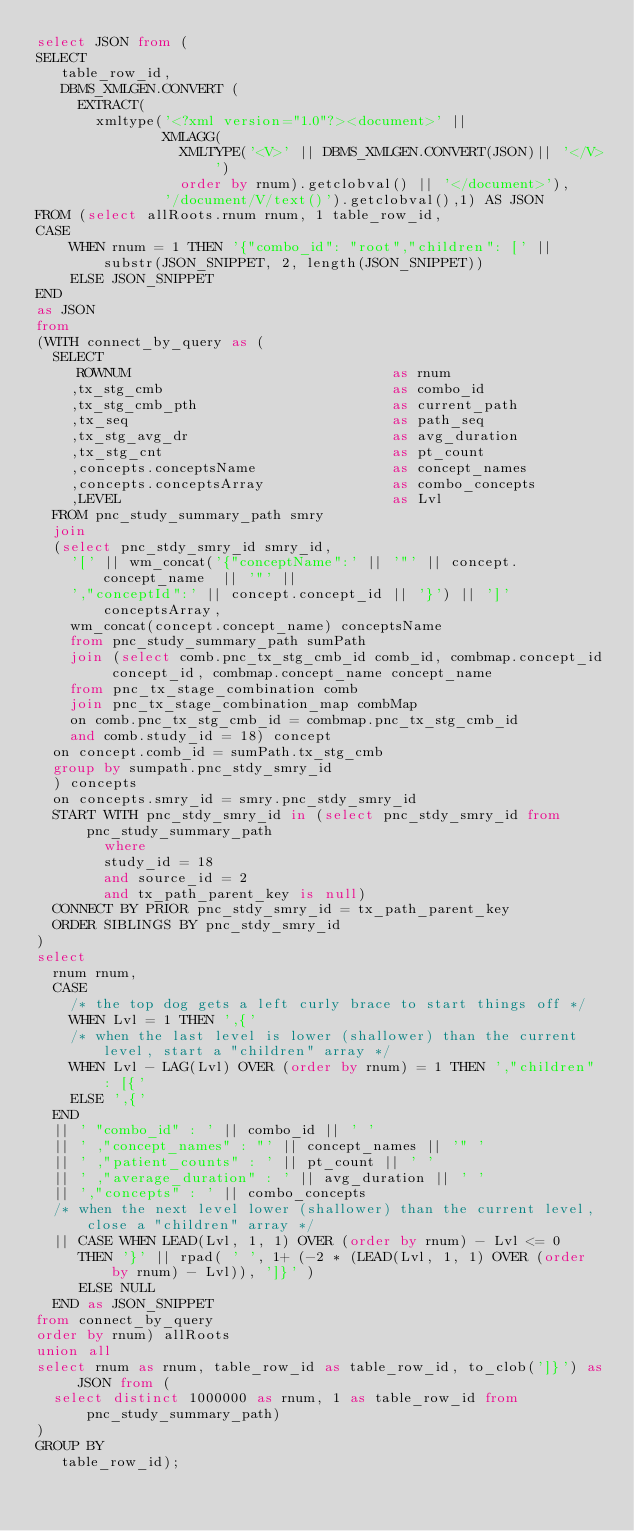Convert code to text. <code><loc_0><loc_0><loc_500><loc_500><_SQL_>select JSON from (
SELECT
   table_row_id,
   DBMS_XMLGEN.CONVERT (
     EXTRACT(
       xmltype('<?xml version="1.0"?><document>' ||
               XMLAGG(
                 XMLTYPE('<V>' || DBMS_XMLGEN.CONVERT(JSON)|| '</V>')
                 order by rnum).getclobval() || '</document>'),
               '/document/V/text()').getclobval(),1) AS JSON
FROM (select allRoots.rnum rnum, 1 table_row_id,
CASE 
    WHEN rnum = 1 THEN '{"combo_id": "root","children": [' || substr(JSON_SNIPPET, 2, length(JSON_SNIPPET))
    ELSE JSON_SNIPPET
END
as JSON
from 
(WITH connect_by_query as (
  SELECT 
     ROWNUM                               as rnum
    ,tx_stg_cmb                           as combo_id
    ,tx_stg_cmb_pth                       as current_path
    ,tx_seq                               as path_seq
    ,tx_stg_avg_dr                        as avg_duration
    ,tx_stg_cnt                           as pt_count
    ,concepts.conceptsName                as concept_names
    ,concepts.conceptsArray               as combo_concepts
    ,LEVEL                                as Lvl
  FROM pnc_study_summary_path smry
  join
  (select pnc_stdy_smry_id smry_id, 
    '[' || wm_concat('{"conceptName":' || '"' || concept.concept_name  || '"' || 
    ',"conceptId":' || concept.concept_id || '}') || ']' conceptsArray,
    wm_concat(concept.concept_name) conceptsName
    from pnc_study_summary_path sumPath
    join (select comb.pnc_tx_stg_cmb_id comb_id, combmap.concept_id concept_id, combmap.concept_name concept_name 
    from pnc_tx_stage_combination comb
    join pnc_tx_stage_combination_map combMap 
    on comb.pnc_tx_stg_cmb_id = combmap.pnc_tx_stg_cmb_id
    and comb.study_id = 18) concept
  on concept.comb_id = sumPath.tx_stg_cmb
  group by sumpath.pnc_stdy_smry_id
  ) concepts
  on concepts.smry_id = smry.pnc_stdy_smry_id
  START WITH pnc_stdy_smry_id in (select pnc_stdy_smry_id from pnc_study_summary_path
        where 
        study_id = 18
        and source_id = 2
        and tx_path_parent_key is null)
  CONNECT BY PRIOR pnc_stdy_smry_id = tx_path_parent_key
  ORDER SIBLINGS BY pnc_stdy_smry_id
)
select 
  rnum rnum,
  CASE 
    /* the top dog gets a left curly brace to start things off */
    WHEN Lvl = 1 THEN ',{'
    /* when the last level is lower (shallower) than the current level, start a "children" array */
    WHEN Lvl - LAG(Lvl) OVER (order by rnum) = 1 THEN ',"children" : [{' 
    ELSE ',{' 
  END 
  || ' "combo_id" : ' || combo_id || ' '
  || ' ,"concept_names" : "' || concept_names || '" '  
  || ' ,"patient_counts" : ' || pt_count || ' '
  || ' ,"average_duration" : ' || avg_duration || ' '
  || ',"concepts" : ' || combo_concepts 
  /* when the next level lower (shallower) than the current level, close a "children" array */
  || CASE WHEN LEAD(Lvl, 1, 1) OVER (order by rnum) - Lvl <= 0 
     THEN '}' || rpad( ' ', 1+ (-2 * (LEAD(Lvl, 1, 1) OVER (order by rnum) - Lvl)), ']}' )
     ELSE NULL 
  END as JSON_SNIPPET
from connect_by_query
order by rnum) allRoots
union all
select rnum as rnum, table_row_id as table_row_id, to_clob(']}') as JSON from (
  select distinct 1000000 as rnum, 1 as table_row_id from pnc_study_summary_path)
)
GROUP BY
   table_row_id);</code> 